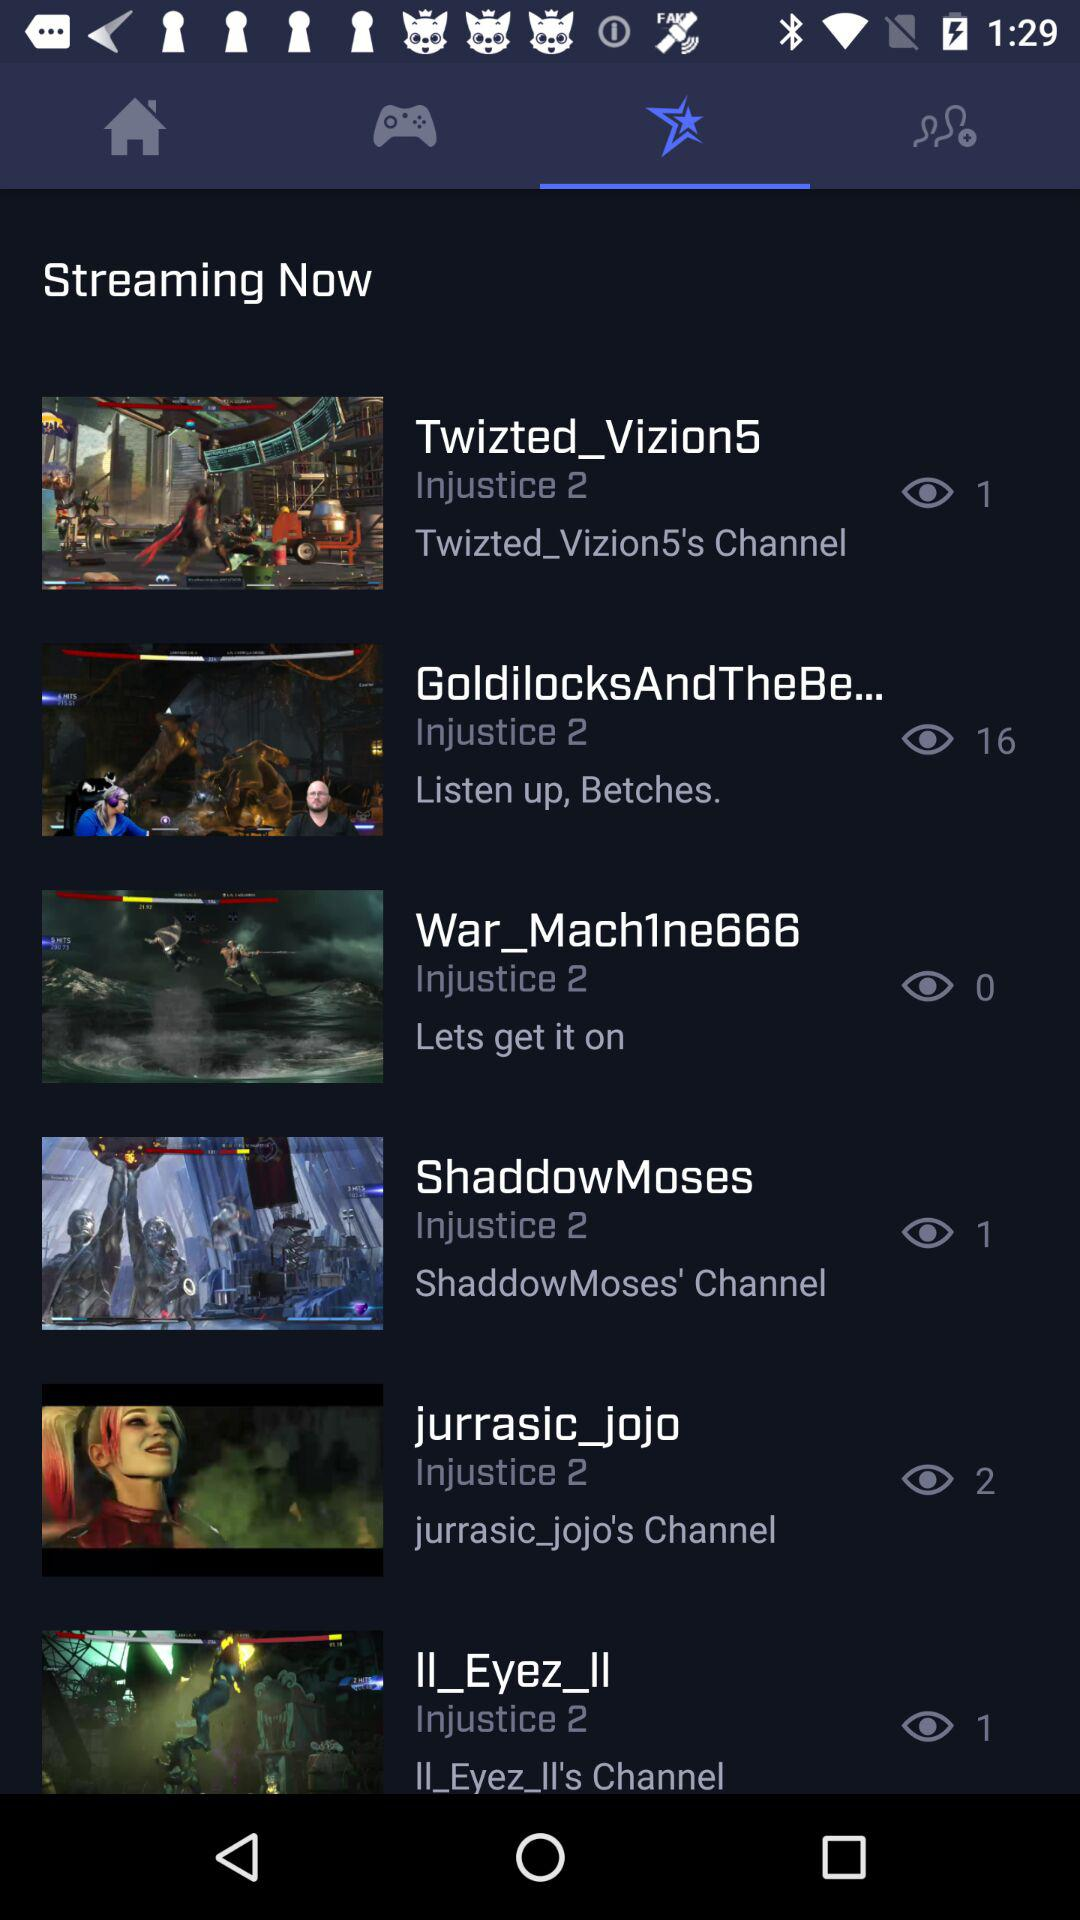What is the number of views on "jurrasic_jojo"? The number of views is 2. 